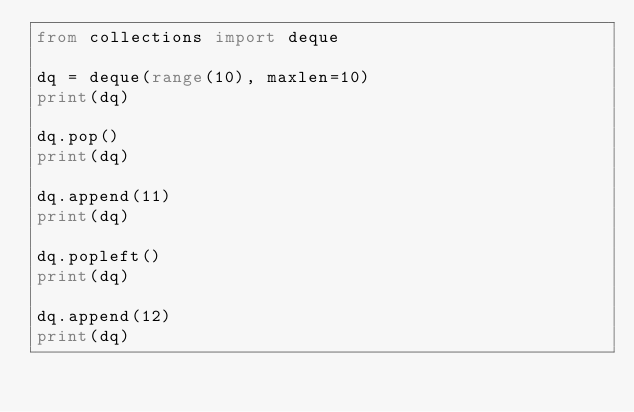Convert code to text. <code><loc_0><loc_0><loc_500><loc_500><_Python_>from collections import deque

dq = deque(range(10), maxlen=10)
print(dq)

dq.pop()
print(dq)

dq.append(11)
print(dq)

dq.popleft()
print(dq)

dq.append(12)
print(dq)
</code> 